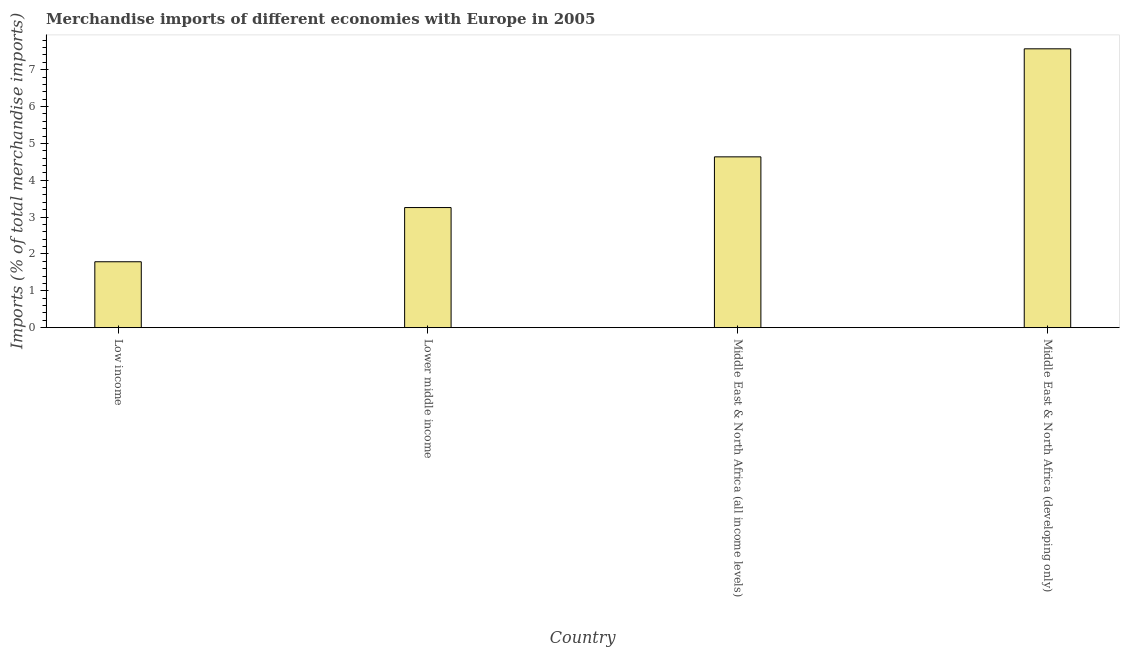What is the title of the graph?
Offer a terse response. Merchandise imports of different economies with Europe in 2005. What is the label or title of the Y-axis?
Make the answer very short. Imports (% of total merchandise imports). What is the merchandise imports in Low income?
Make the answer very short. 1.79. Across all countries, what is the maximum merchandise imports?
Make the answer very short. 7.57. Across all countries, what is the minimum merchandise imports?
Your response must be concise. 1.79. In which country was the merchandise imports maximum?
Make the answer very short. Middle East & North Africa (developing only). What is the sum of the merchandise imports?
Ensure brevity in your answer.  17.25. What is the difference between the merchandise imports in Low income and Lower middle income?
Your response must be concise. -1.47. What is the average merchandise imports per country?
Provide a short and direct response. 4.31. What is the median merchandise imports?
Keep it short and to the point. 3.95. What is the ratio of the merchandise imports in Low income to that in Lower middle income?
Your answer should be very brief. 0.55. Is the merchandise imports in Middle East & North Africa (all income levels) less than that in Middle East & North Africa (developing only)?
Your answer should be compact. Yes. Is the difference between the merchandise imports in Lower middle income and Middle East & North Africa (developing only) greater than the difference between any two countries?
Ensure brevity in your answer.  No. What is the difference between the highest and the second highest merchandise imports?
Your answer should be compact. 2.93. Is the sum of the merchandise imports in Middle East & North Africa (all income levels) and Middle East & North Africa (developing only) greater than the maximum merchandise imports across all countries?
Your answer should be very brief. Yes. What is the difference between the highest and the lowest merchandise imports?
Offer a very short reply. 5.78. In how many countries, is the merchandise imports greater than the average merchandise imports taken over all countries?
Ensure brevity in your answer.  2. What is the difference between two consecutive major ticks on the Y-axis?
Your response must be concise. 1. What is the Imports (% of total merchandise imports) of Low income?
Make the answer very short. 1.79. What is the Imports (% of total merchandise imports) in Lower middle income?
Offer a terse response. 3.26. What is the Imports (% of total merchandise imports) of Middle East & North Africa (all income levels)?
Ensure brevity in your answer.  4.64. What is the Imports (% of total merchandise imports) of Middle East & North Africa (developing only)?
Your answer should be compact. 7.57. What is the difference between the Imports (% of total merchandise imports) in Low income and Lower middle income?
Provide a short and direct response. -1.47. What is the difference between the Imports (% of total merchandise imports) in Low income and Middle East & North Africa (all income levels)?
Provide a short and direct response. -2.85. What is the difference between the Imports (% of total merchandise imports) in Low income and Middle East & North Africa (developing only)?
Provide a short and direct response. -5.78. What is the difference between the Imports (% of total merchandise imports) in Lower middle income and Middle East & North Africa (all income levels)?
Your answer should be very brief. -1.38. What is the difference between the Imports (% of total merchandise imports) in Lower middle income and Middle East & North Africa (developing only)?
Ensure brevity in your answer.  -4.31. What is the difference between the Imports (% of total merchandise imports) in Middle East & North Africa (all income levels) and Middle East & North Africa (developing only)?
Provide a succinct answer. -2.93. What is the ratio of the Imports (% of total merchandise imports) in Low income to that in Lower middle income?
Provide a succinct answer. 0.55. What is the ratio of the Imports (% of total merchandise imports) in Low income to that in Middle East & North Africa (all income levels)?
Your response must be concise. 0.39. What is the ratio of the Imports (% of total merchandise imports) in Low income to that in Middle East & North Africa (developing only)?
Offer a very short reply. 0.24. What is the ratio of the Imports (% of total merchandise imports) in Lower middle income to that in Middle East & North Africa (all income levels)?
Offer a very short reply. 0.7. What is the ratio of the Imports (% of total merchandise imports) in Lower middle income to that in Middle East & North Africa (developing only)?
Offer a terse response. 0.43. What is the ratio of the Imports (% of total merchandise imports) in Middle East & North Africa (all income levels) to that in Middle East & North Africa (developing only)?
Provide a succinct answer. 0.61. 